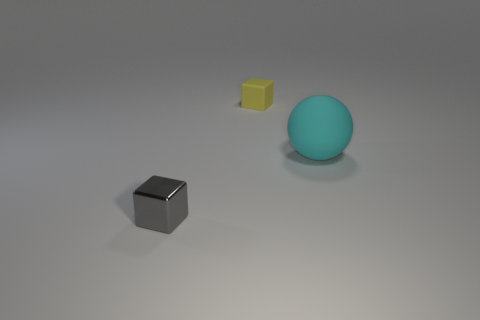Is there any other thing that is the same size as the sphere?
Your answer should be very brief. No. Are the gray thing and the small object that is behind the gray shiny object made of the same material?
Provide a succinct answer. No. What number of big brown cubes are made of the same material as the sphere?
Offer a terse response. 0. What shape is the tiny object that is left of the small matte thing?
Offer a terse response. Cube. Do the tiny thing that is behind the matte ball and the small object in front of the tiny yellow block have the same material?
Offer a very short reply. No. Is there a cyan object that has the same shape as the yellow object?
Provide a succinct answer. No. What number of objects are shiny things that are to the left of the tiny yellow thing or large yellow objects?
Ensure brevity in your answer.  1. Is the number of big cyan matte objects that are behind the yellow object greater than the number of large rubber objects that are to the left of the big sphere?
Keep it short and to the point. No. What number of rubber things are either yellow objects or large balls?
Your response must be concise. 2. Are there fewer yellow matte blocks that are on the left side of the gray shiny block than cyan rubber objects that are to the left of the big cyan matte ball?
Your answer should be compact. No. 